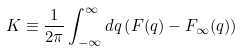Convert formula to latex. <formula><loc_0><loc_0><loc_500><loc_500>K \equiv \frac { 1 } { 2 \pi } \int _ { - \infty } ^ { \infty } d q \left ( F ( q ) - F _ { \infty } ( q ) \right )</formula> 